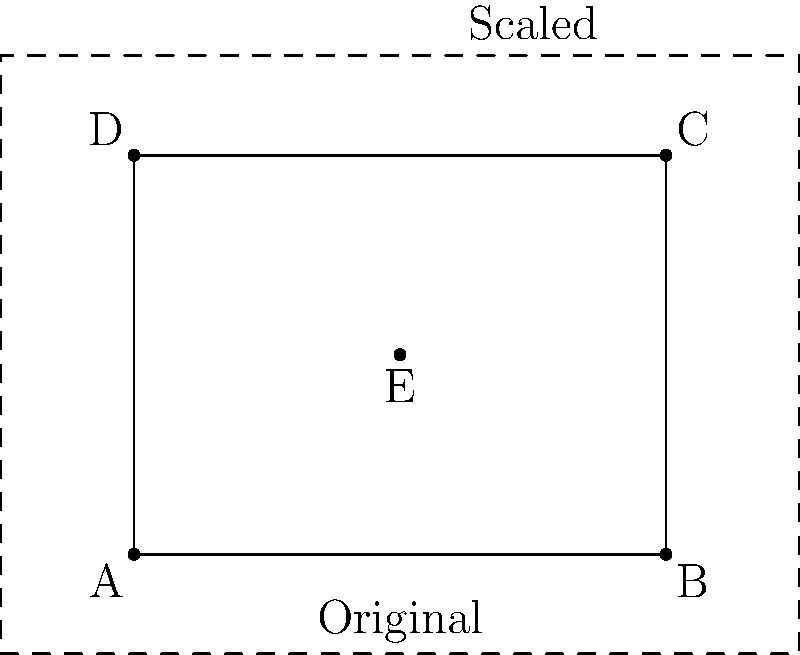In your papier-mâché workshop, you want to resize an intricate pattern. The original pattern is represented by rectangle ABCD with center point E. If you scale the pattern by a factor of 1.5 from point E, what will be the new area of the scaled pattern? To solve this problem, let's follow these steps:

1. Determine the dimensions of the original rectangle:
   Width = 4 units
   Height = 3 units

2. Calculate the area of the original rectangle:
   $A_{original} = 4 \times 3 = 12$ square units

3. Understand the scaling factor:
   The pattern is scaled by a factor of 1.5 from point E

4. Apply the scaling factor to the area:
   When a two-dimensional shape is scaled by a factor $k$, its area is scaled by $k^2$
   $A_{new} = A_{original} \times k^2$
   $A_{new} = 12 \times 1.5^2 = 12 \times 2.25 = 27$ square units

Therefore, the new area of the scaled pattern is 27 square units.
Answer: 27 square units 